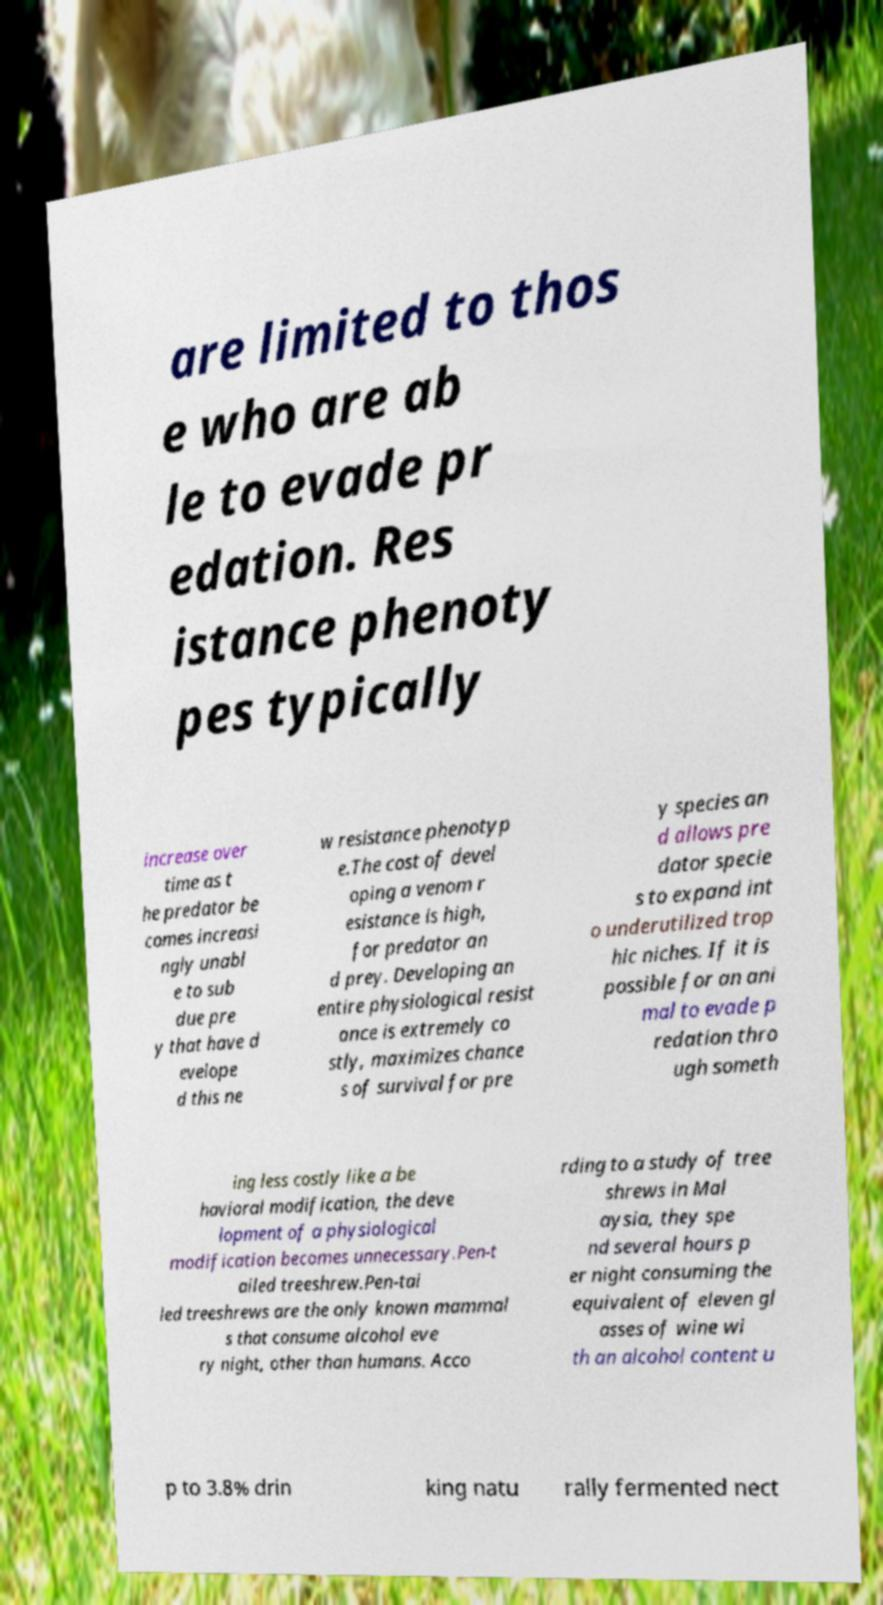Could you assist in decoding the text presented in this image and type it out clearly? are limited to thos e who are ab le to evade pr edation. Res istance phenoty pes typically increase over time as t he predator be comes increasi ngly unabl e to sub due pre y that have d evelope d this ne w resistance phenotyp e.The cost of devel oping a venom r esistance is high, for predator an d prey. Developing an entire physiological resist ance is extremely co stly, maximizes chance s of survival for pre y species an d allows pre dator specie s to expand int o underutilized trop hic niches. If it is possible for an ani mal to evade p redation thro ugh someth ing less costly like a be havioral modification, the deve lopment of a physiological modification becomes unnecessary.Pen-t ailed treeshrew.Pen-tai led treeshrews are the only known mammal s that consume alcohol eve ry night, other than humans. Acco rding to a study of tree shrews in Mal aysia, they spe nd several hours p er night consuming the equivalent of eleven gl asses of wine wi th an alcohol content u p to 3.8% drin king natu rally fermented nect 